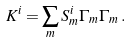Convert formula to latex. <formula><loc_0><loc_0><loc_500><loc_500>K ^ { i } = \sum _ { m } S _ { m } ^ { i } \Gamma _ { m } \Gamma _ { m } \, .</formula> 